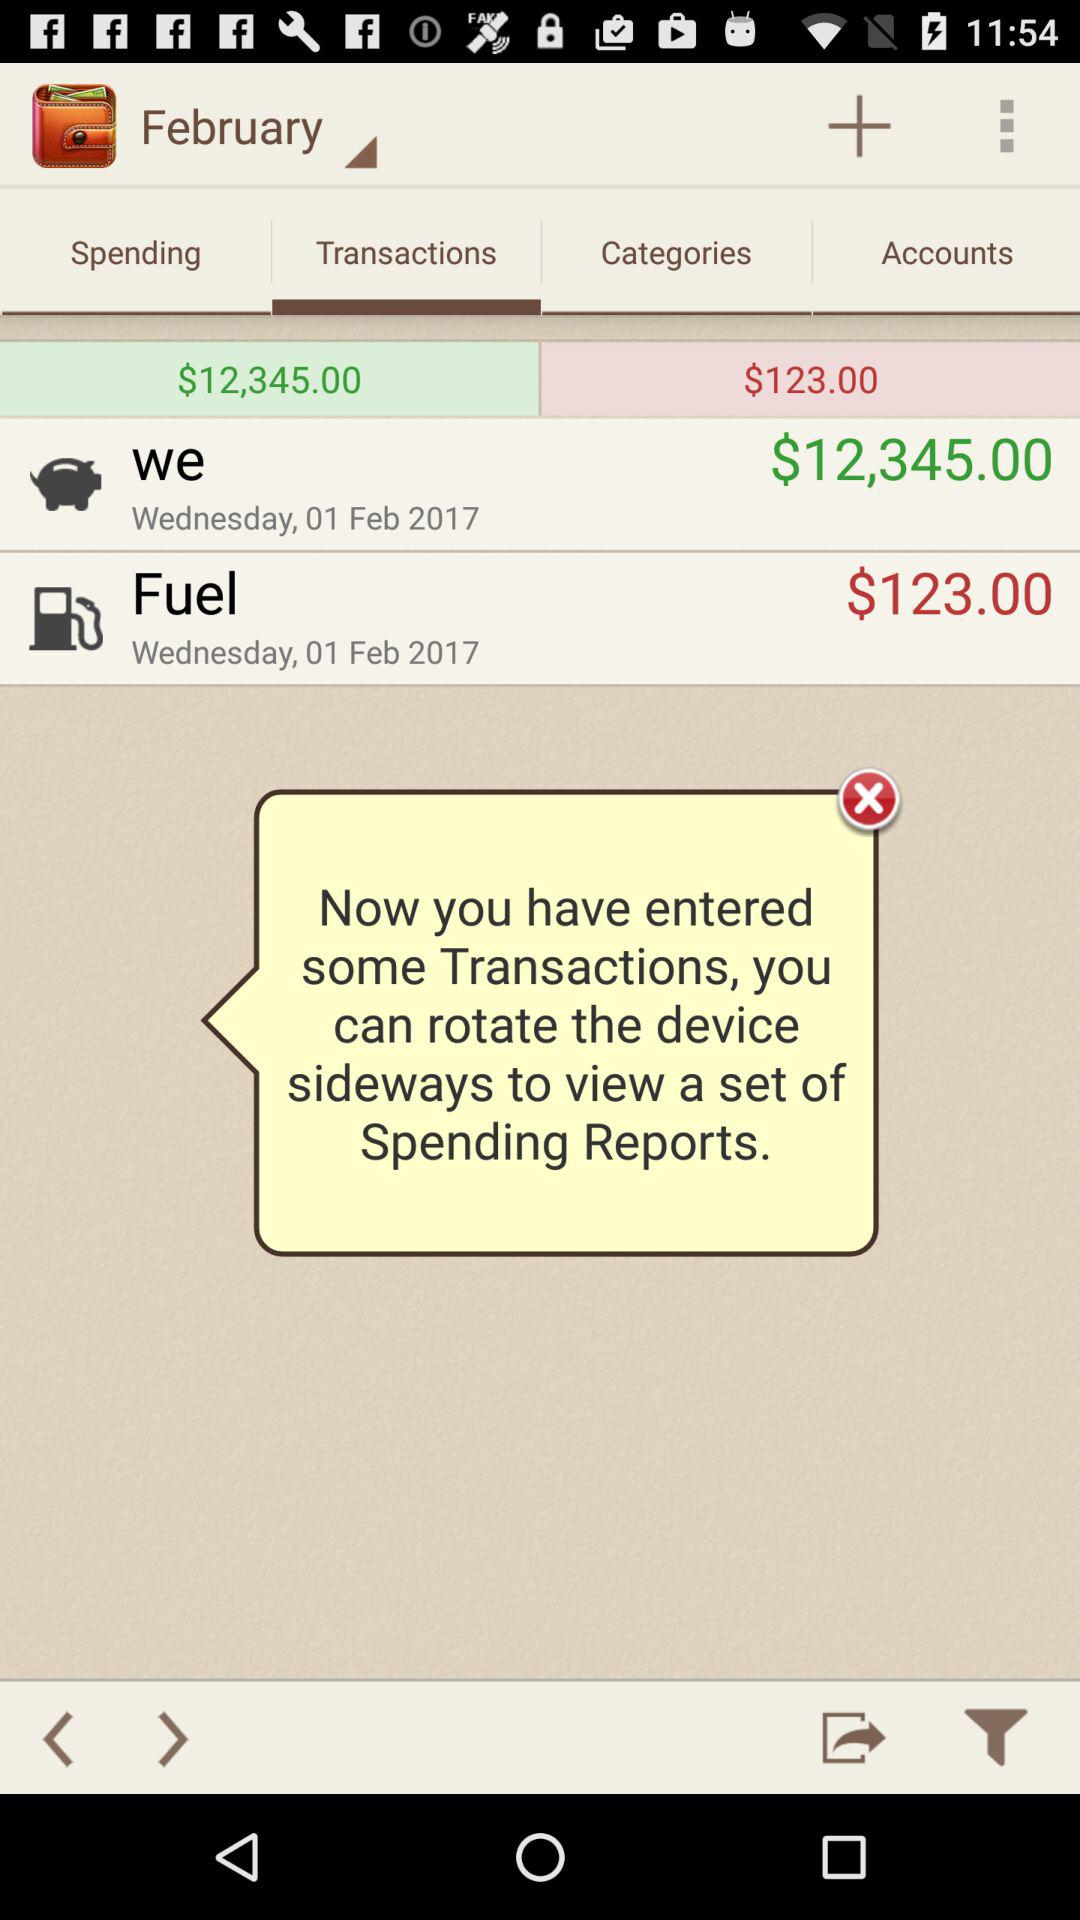Which tab is selected? The selected tab is "Transactions". 